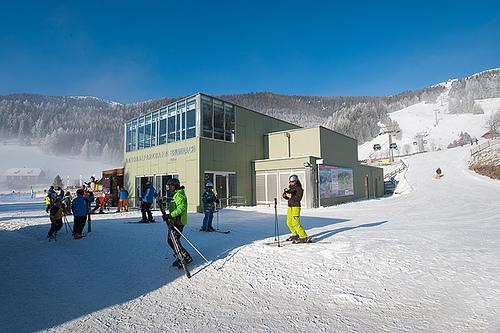Question: what are the people doing?
Choices:
A. Eating dinner.
B. Going skiing.
C. Watching a movie.
D. Sightseeing.
Answer with the letter. Answer: B Question: why are the people outside?
Choices:
A. They are skiing.
B. They are skating.
C. They are exercising.
D. They are having a picnic.
Answer with the letter. Answer: A Question: who is skiing?
Choices:
A. A young child.
B. The people at the resort.
C. A middle aged man.
D. A teenager.
Answer with the letter. Answer: B Question: how many people are skiing?
Choices:
A. 8.
B. 9.
C. 6.
D. 10.
Answer with the letter. Answer: D Question: when did they go skiing?
Choices:
A. In the early morning.
B. At noon.
C. At night.
D. During the day.
Answer with the letter. Answer: D Question: what is in their hands?
Choices:
A. A cup of hot cocoa.
B. Ski poles.
C. Shopping bags.
D. Silver coins.
Answer with the letter. Answer: B Question: where are they skiing?
Choices:
A. In Colorado.
B. At a ski resort.
C. In Vermont.
D. On the slopes.
Answer with the letter. Answer: D 